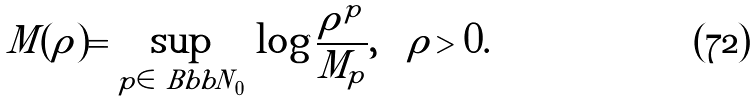Convert formula to latex. <formula><loc_0><loc_0><loc_500><loc_500>M ( \rho ) = \sup _ { p \in { \ B b b N } _ { 0 } } \, \log \frac { \rho ^ { p } } { M _ { p } } , \quad \rho > 0 .</formula> 